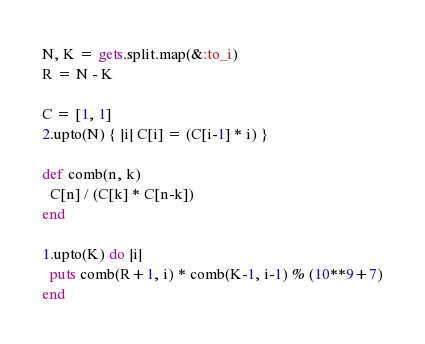Convert code to text. <code><loc_0><loc_0><loc_500><loc_500><_Ruby_>N, K = gets.split.map(&:to_i)
R = N - K

C = [1, 1]
2.upto(N) { |i| C[i] = (C[i-1] * i) }

def comb(n, k)
  C[n] / (C[k] * C[n-k])
end

1.upto(K) do |i|
  puts comb(R+1, i) * comb(K-1, i-1) % (10**9+7)
end</code> 